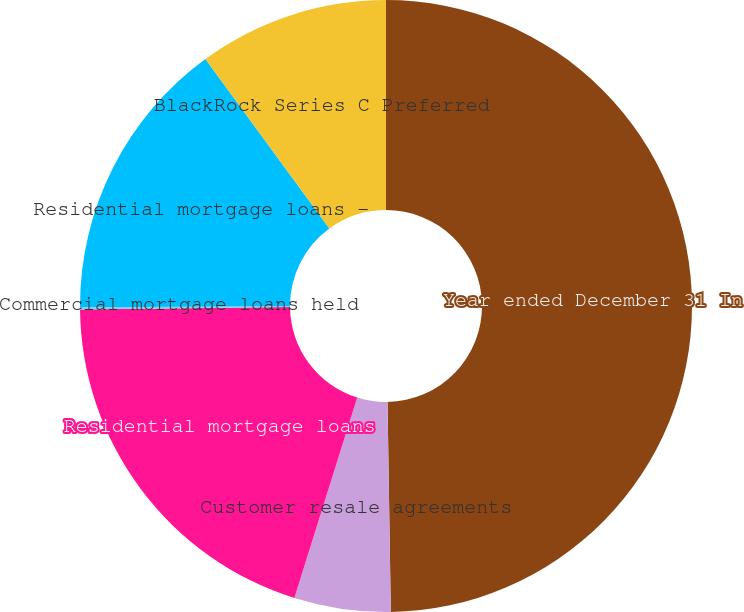Convert chart. <chart><loc_0><loc_0><loc_500><loc_500><pie_chart><fcel>Year ended December 31 In<fcel>Customer resale agreements<fcel>Residential mortgage loans<fcel>Commercial mortgage loans held<fcel>Residential mortgage loans -<fcel>BlackRock Series C Preferred<nl><fcel>49.75%<fcel>5.09%<fcel>19.98%<fcel>0.12%<fcel>15.01%<fcel>10.05%<nl></chart> 